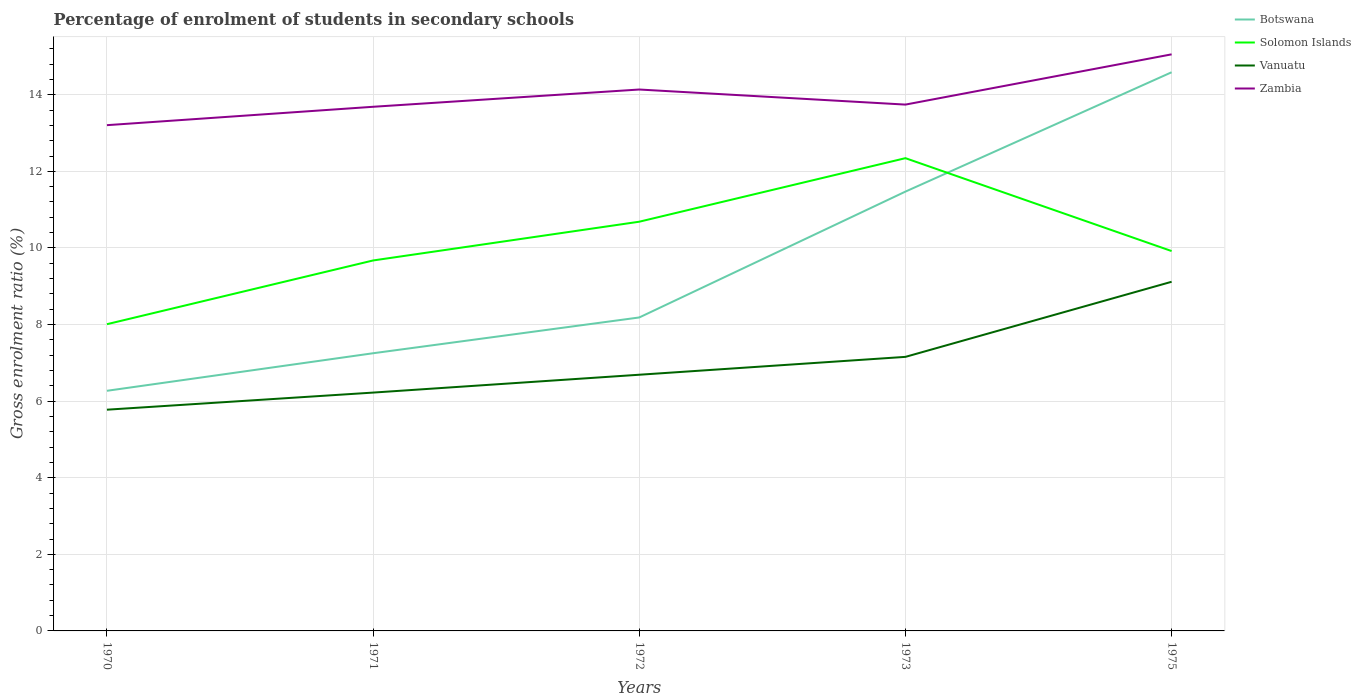Is the number of lines equal to the number of legend labels?
Provide a short and direct response. Yes. Across all years, what is the maximum percentage of students enrolled in secondary schools in Solomon Islands?
Provide a succinct answer. 8.01. In which year was the percentage of students enrolled in secondary schools in Botswana maximum?
Offer a terse response. 1970. What is the total percentage of students enrolled in secondary schools in Zambia in the graph?
Keep it short and to the point. -0.06. What is the difference between the highest and the second highest percentage of students enrolled in secondary schools in Vanuatu?
Make the answer very short. 3.34. Is the percentage of students enrolled in secondary schools in Vanuatu strictly greater than the percentage of students enrolled in secondary schools in Botswana over the years?
Your response must be concise. Yes. How many years are there in the graph?
Ensure brevity in your answer.  5. Are the values on the major ticks of Y-axis written in scientific E-notation?
Your response must be concise. No. How are the legend labels stacked?
Offer a very short reply. Vertical. What is the title of the graph?
Offer a terse response. Percentage of enrolment of students in secondary schools. Does "Guam" appear as one of the legend labels in the graph?
Provide a short and direct response. No. What is the Gross enrolment ratio (%) of Botswana in 1970?
Your answer should be compact. 6.27. What is the Gross enrolment ratio (%) of Solomon Islands in 1970?
Provide a short and direct response. 8.01. What is the Gross enrolment ratio (%) in Vanuatu in 1970?
Your response must be concise. 5.78. What is the Gross enrolment ratio (%) in Zambia in 1970?
Your response must be concise. 13.21. What is the Gross enrolment ratio (%) of Botswana in 1971?
Your answer should be compact. 7.25. What is the Gross enrolment ratio (%) in Solomon Islands in 1971?
Provide a short and direct response. 9.67. What is the Gross enrolment ratio (%) of Vanuatu in 1971?
Give a very brief answer. 6.22. What is the Gross enrolment ratio (%) in Zambia in 1971?
Provide a succinct answer. 13.69. What is the Gross enrolment ratio (%) of Botswana in 1972?
Ensure brevity in your answer.  8.18. What is the Gross enrolment ratio (%) of Solomon Islands in 1972?
Provide a short and direct response. 10.68. What is the Gross enrolment ratio (%) in Vanuatu in 1972?
Provide a succinct answer. 6.69. What is the Gross enrolment ratio (%) of Zambia in 1972?
Keep it short and to the point. 14.14. What is the Gross enrolment ratio (%) of Botswana in 1973?
Give a very brief answer. 11.47. What is the Gross enrolment ratio (%) in Solomon Islands in 1973?
Provide a short and direct response. 12.34. What is the Gross enrolment ratio (%) in Vanuatu in 1973?
Offer a terse response. 7.16. What is the Gross enrolment ratio (%) in Zambia in 1973?
Offer a terse response. 13.74. What is the Gross enrolment ratio (%) in Botswana in 1975?
Give a very brief answer. 14.59. What is the Gross enrolment ratio (%) in Solomon Islands in 1975?
Your answer should be compact. 9.92. What is the Gross enrolment ratio (%) in Vanuatu in 1975?
Your answer should be very brief. 9.12. What is the Gross enrolment ratio (%) of Zambia in 1975?
Make the answer very short. 15.05. Across all years, what is the maximum Gross enrolment ratio (%) of Botswana?
Your response must be concise. 14.59. Across all years, what is the maximum Gross enrolment ratio (%) of Solomon Islands?
Provide a short and direct response. 12.34. Across all years, what is the maximum Gross enrolment ratio (%) in Vanuatu?
Offer a terse response. 9.12. Across all years, what is the maximum Gross enrolment ratio (%) of Zambia?
Provide a short and direct response. 15.05. Across all years, what is the minimum Gross enrolment ratio (%) of Botswana?
Your response must be concise. 6.27. Across all years, what is the minimum Gross enrolment ratio (%) of Solomon Islands?
Ensure brevity in your answer.  8.01. Across all years, what is the minimum Gross enrolment ratio (%) of Vanuatu?
Offer a very short reply. 5.78. Across all years, what is the minimum Gross enrolment ratio (%) of Zambia?
Your response must be concise. 13.21. What is the total Gross enrolment ratio (%) of Botswana in the graph?
Your response must be concise. 47.76. What is the total Gross enrolment ratio (%) in Solomon Islands in the graph?
Your answer should be compact. 50.63. What is the total Gross enrolment ratio (%) in Vanuatu in the graph?
Your response must be concise. 34.96. What is the total Gross enrolment ratio (%) of Zambia in the graph?
Ensure brevity in your answer.  69.82. What is the difference between the Gross enrolment ratio (%) in Botswana in 1970 and that in 1971?
Ensure brevity in your answer.  -0.98. What is the difference between the Gross enrolment ratio (%) of Solomon Islands in 1970 and that in 1971?
Your answer should be very brief. -1.66. What is the difference between the Gross enrolment ratio (%) of Vanuatu in 1970 and that in 1971?
Your answer should be compact. -0.45. What is the difference between the Gross enrolment ratio (%) of Zambia in 1970 and that in 1971?
Your response must be concise. -0.48. What is the difference between the Gross enrolment ratio (%) in Botswana in 1970 and that in 1972?
Your response must be concise. -1.91. What is the difference between the Gross enrolment ratio (%) of Solomon Islands in 1970 and that in 1972?
Your answer should be compact. -2.68. What is the difference between the Gross enrolment ratio (%) in Vanuatu in 1970 and that in 1972?
Ensure brevity in your answer.  -0.91. What is the difference between the Gross enrolment ratio (%) in Zambia in 1970 and that in 1972?
Your answer should be very brief. -0.93. What is the difference between the Gross enrolment ratio (%) in Botswana in 1970 and that in 1973?
Offer a very short reply. -5.2. What is the difference between the Gross enrolment ratio (%) of Solomon Islands in 1970 and that in 1973?
Keep it short and to the point. -4.33. What is the difference between the Gross enrolment ratio (%) in Vanuatu in 1970 and that in 1973?
Offer a very short reply. -1.38. What is the difference between the Gross enrolment ratio (%) in Zambia in 1970 and that in 1973?
Make the answer very short. -0.54. What is the difference between the Gross enrolment ratio (%) of Botswana in 1970 and that in 1975?
Provide a short and direct response. -8.32. What is the difference between the Gross enrolment ratio (%) in Solomon Islands in 1970 and that in 1975?
Ensure brevity in your answer.  -1.91. What is the difference between the Gross enrolment ratio (%) in Vanuatu in 1970 and that in 1975?
Make the answer very short. -3.34. What is the difference between the Gross enrolment ratio (%) of Zambia in 1970 and that in 1975?
Offer a very short reply. -1.85. What is the difference between the Gross enrolment ratio (%) in Botswana in 1971 and that in 1972?
Your answer should be compact. -0.93. What is the difference between the Gross enrolment ratio (%) in Solomon Islands in 1971 and that in 1972?
Your answer should be very brief. -1.01. What is the difference between the Gross enrolment ratio (%) in Vanuatu in 1971 and that in 1972?
Give a very brief answer. -0.47. What is the difference between the Gross enrolment ratio (%) in Zambia in 1971 and that in 1972?
Offer a terse response. -0.45. What is the difference between the Gross enrolment ratio (%) in Botswana in 1971 and that in 1973?
Provide a short and direct response. -4.22. What is the difference between the Gross enrolment ratio (%) in Solomon Islands in 1971 and that in 1973?
Give a very brief answer. -2.67. What is the difference between the Gross enrolment ratio (%) of Vanuatu in 1971 and that in 1973?
Offer a very short reply. -0.93. What is the difference between the Gross enrolment ratio (%) of Zambia in 1971 and that in 1973?
Offer a terse response. -0.06. What is the difference between the Gross enrolment ratio (%) of Botswana in 1971 and that in 1975?
Your answer should be very brief. -7.34. What is the difference between the Gross enrolment ratio (%) in Solomon Islands in 1971 and that in 1975?
Give a very brief answer. -0.25. What is the difference between the Gross enrolment ratio (%) of Vanuatu in 1971 and that in 1975?
Provide a succinct answer. -2.89. What is the difference between the Gross enrolment ratio (%) in Zambia in 1971 and that in 1975?
Ensure brevity in your answer.  -1.37. What is the difference between the Gross enrolment ratio (%) in Botswana in 1972 and that in 1973?
Offer a terse response. -3.29. What is the difference between the Gross enrolment ratio (%) of Solomon Islands in 1972 and that in 1973?
Give a very brief answer. -1.66. What is the difference between the Gross enrolment ratio (%) of Vanuatu in 1972 and that in 1973?
Make the answer very short. -0.47. What is the difference between the Gross enrolment ratio (%) in Zambia in 1972 and that in 1973?
Your answer should be compact. 0.39. What is the difference between the Gross enrolment ratio (%) of Botswana in 1972 and that in 1975?
Your response must be concise. -6.4. What is the difference between the Gross enrolment ratio (%) in Solomon Islands in 1972 and that in 1975?
Your answer should be compact. 0.77. What is the difference between the Gross enrolment ratio (%) in Vanuatu in 1972 and that in 1975?
Your answer should be compact. -2.43. What is the difference between the Gross enrolment ratio (%) in Zambia in 1972 and that in 1975?
Your answer should be very brief. -0.92. What is the difference between the Gross enrolment ratio (%) in Botswana in 1973 and that in 1975?
Offer a very short reply. -3.12. What is the difference between the Gross enrolment ratio (%) in Solomon Islands in 1973 and that in 1975?
Provide a short and direct response. 2.43. What is the difference between the Gross enrolment ratio (%) of Vanuatu in 1973 and that in 1975?
Give a very brief answer. -1.96. What is the difference between the Gross enrolment ratio (%) in Zambia in 1973 and that in 1975?
Provide a succinct answer. -1.31. What is the difference between the Gross enrolment ratio (%) of Botswana in 1970 and the Gross enrolment ratio (%) of Solomon Islands in 1971?
Provide a succinct answer. -3.4. What is the difference between the Gross enrolment ratio (%) of Botswana in 1970 and the Gross enrolment ratio (%) of Vanuatu in 1971?
Your answer should be very brief. 0.05. What is the difference between the Gross enrolment ratio (%) in Botswana in 1970 and the Gross enrolment ratio (%) in Zambia in 1971?
Your answer should be very brief. -7.42. What is the difference between the Gross enrolment ratio (%) of Solomon Islands in 1970 and the Gross enrolment ratio (%) of Vanuatu in 1971?
Your answer should be compact. 1.79. What is the difference between the Gross enrolment ratio (%) in Solomon Islands in 1970 and the Gross enrolment ratio (%) in Zambia in 1971?
Your response must be concise. -5.68. What is the difference between the Gross enrolment ratio (%) in Vanuatu in 1970 and the Gross enrolment ratio (%) in Zambia in 1971?
Keep it short and to the point. -7.91. What is the difference between the Gross enrolment ratio (%) in Botswana in 1970 and the Gross enrolment ratio (%) in Solomon Islands in 1972?
Keep it short and to the point. -4.41. What is the difference between the Gross enrolment ratio (%) of Botswana in 1970 and the Gross enrolment ratio (%) of Vanuatu in 1972?
Offer a terse response. -0.42. What is the difference between the Gross enrolment ratio (%) of Botswana in 1970 and the Gross enrolment ratio (%) of Zambia in 1972?
Make the answer very short. -7.87. What is the difference between the Gross enrolment ratio (%) in Solomon Islands in 1970 and the Gross enrolment ratio (%) in Vanuatu in 1972?
Your response must be concise. 1.32. What is the difference between the Gross enrolment ratio (%) in Solomon Islands in 1970 and the Gross enrolment ratio (%) in Zambia in 1972?
Offer a terse response. -6.13. What is the difference between the Gross enrolment ratio (%) of Vanuatu in 1970 and the Gross enrolment ratio (%) of Zambia in 1972?
Offer a very short reply. -8.36. What is the difference between the Gross enrolment ratio (%) of Botswana in 1970 and the Gross enrolment ratio (%) of Solomon Islands in 1973?
Provide a succinct answer. -6.07. What is the difference between the Gross enrolment ratio (%) in Botswana in 1970 and the Gross enrolment ratio (%) in Vanuatu in 1973?
Provide a succinct answer. -0.89. What is the difference between the Gross enrolment ratio (%) in Botswana in 1970 and the Gross enrolment ratio (%) in Zambia in 1973?
Offer a terse response. -7.47. What is the difference between the Gross enrolment ratio (%) of Solomon Islands in 1970 and the Gross enrolment ratio (%) of Vanuatu in 1973?
Your answer should be very brief. 0.85. What is the difference between the Gross enrolment ratio (%) of Solomon Islands in 1970 and the Gross enrolment ratio (%) of Zambia in 1973?
Your answer should be compact. -5.73. What is the difference between the Gross enrolment ratio (%) in Vanuatu in 1970 and the Gross enrolment ratio (%) in Zambia in 1973?
Your response must be concise. -7.97. What is the difference between the Gross enrolment ratio (%) of Botswana in 1970 and the Gross enrolment ratio (%) of Solomon Islands in 1975?
Give a very brief answer. -3.65. What is the difference between the Gross enrolment ratio (%) in Botswana in 1970 and the Gross enrolment ratio (%) in Vanuatu in 1975?
Keep it short and to the point. -2.85. What is the difference between the Gross enrolment ratio (%) of Botswana in 1970 and the Gross enrolment ratio (%) of Zambia in 1975?
Your answer should be very brief. -8.78. What is the difference between the Gross enrolment ratio (%) in Solomon Islands in 1970 and the Gross enrolment ratio (%) in Vanuatu in 1975?
Provide a short and direct response. -1.11. What is the difference between the Gross enrolment ratio (%) in Solomon Islands in 1970 and the Gross enrolment ratio (%) in Zambia in 1975?
Offer a terse response. -7.05. What is the difference between the Gross enrolment ratio (%) of Vanuatu in 1970 and the Gross enrolment ratio (%) of Zambia in 1975?
Ensure brevity in your answer.  -9.28. What is the difference between the Gross enrolment ratio (%) of Botswana in 1971 and the Gross enrolment ratio (%) of Solomon Islands in 1972?
Your answer should be compact. -3.43. What is the difference between the Gross enrolment ratio (%) in Botswana in 1971 and the Gross enrolment ratio (%) in Vanuatu in 1972?
Offer a very short reply. 0.56. What is the difference between the Gross enrolment ratio (%) in Botswana in 1971 and the Gross enrolment ratio (%) in Zambia in 1972?
Your answer should be compact. -6.89. What is the difference between the Gross enrolment ratio (%) in Solomon Islands in 1971 and the Gross enrolment ratio (%) in Vanuatu in 1972?
Give a very brief answer. 2.98. What is the difference between the Gross enrolment ratio (%) in Solomon Islands in 1971 and the Gross enrolment ratio (%) in Zambia in 1972?
Your answer should be compact. -4.46. What is the difference between the Gross enrolment ratio (%) of Vanuatu in 1971 and the Gross enrolment ratio (%) of Zambia in 1972?
Ensure brevity in your answer.  -7.91. What is the difference between the Gross enrolment ratio (%) in Botswana in 1971 and the Gross enrolment ratio (%) in Solomon Islands in 1973?
Keep it short and to the point. -5.09. What is the difference between the Gross enrolment ratio (%) in Botswana in 1971 and the Gross enrolment ratio (%) in Vanuatu in 1973?
Offer a very short reply. 0.09. What is the difference between the Gross enrolment ratio (%) in Botswana in 1971 and the Gross enrolment ratio (%) in Zambia in 1973?
Provide a succinct answer. -6.49. What is the difference between the Gross enrolment ratio (%) of Solomon Islands in 1971 and the Gross enrolment ratio (%) of Vanuatu in 1973?
Offer a very short reply. 2.52. What is the difference between the Gross enrolment ratio (%) of Solomon Islands in 1971 and the Gross enrolment ratio (%) of Zambia in 1973?
Offer a terse response. -4.07. What is the difference between the Gross enrolment ratio (%) of Vanuatu in 1971 and the Gross enrolment ratio (%) of Zambia in 1973?
Offer a terse response. -7.52. What is the difference between the Gross enrolment ratio (%) in Botswana in 1971 and the Gross enrolment ratio (%) in Solomon Islands in 1975?
Provide a succinct answer. -2.67. What is the difference between the Gross enrolment ratio (%) in Botswana in 1971 and the Gross enrolment ratio (%) in Vanuatu in 1975?
Keep it short and to the point. -1.87. What is the difference between the Gross enrolment ratio (%) of Botswana in 1971 and the Gross enrolment ratio (%) of Zambia in 1975?
Provide a short and direct response. -7.8. What is the difference between the Gross enrolment ratio (%) in Solomon Islands in 1971 and the Gross enrolment ratio (%) in Vanuatu in 1975?
Your answer should be very brief. 0.56. What is the difference between the Gross enrolment ratio (%) in Solomon Islands in 1971 and the Gross enrolment ratio (%) in Zambia in 1975?
Provide a succinct answer. -5.38. What is the difference between the Gross enrolment ratio (%) of Vanuatu in 1971 and the Gross enrolment ratio (%) of Zambia in 1975?
Provide a succinct answer. -8.83. What is the difference between the Gross enrolment ratio (%) of Botswana in 1972 and the Gross enrolment ratio (%) of Solomon Islands in 1973?
Ensure brevity in your answer.  -4.16. What is the difference between the Gross enrolment ratio (%) of Botswana in 1972 and the Gross enrolment ratio (%) of Zambia in 1973?
Make the answer very short. -5.56. What is the difference between the Gross enrolment ratio (%) of Solomon Islands in 1972 and the Gross enrolment ratio (%) of Vanuatu in 1973?
Provide a succinct answer. 3.53. What is the difference between the Gross enrolment ratio (%) in Solomon Islands in 1972 and the Gross enrolment ratio (%) in Zambia in 1973?
Offer a terse response. -3.06. What is the difference between the Gross enrolment ratio (%) of Vanuatu in 1972 and the Gross enrolment ratio (%) of Zambia in 1973?
Offer a terse response. -7.05. What is the difference between the Gross enrolment ratio (%) in Botswana in 1972 and the Gross enrolment ratio (%) in Solomon Islands in 1975?
Offer a terse response. -1.73. What is the difference between the Gross enrolment ratio (%) of Botswana in 1972 and the Gross enrolment ratio (%) of Vanuatu in 1975?
Make the answer very short. -0.93. What is the difference between the Gross enrolment ratio (%) of Botswana in 1972 and the Gross enrolment ratio (%) of Zambia in 1975?
Your response must be concise. -6.87. What is the difference between the Gross enrolment ratio (%) of Solomon Islands in 1972 and the Gross enrolment ratio (%) of Vanuatu in 1975?
Your response must be concise. 1.57. What is the difference between the Gross enrolment ratio (%) of Solomon Islands in 1972 and the Gross enrolment ratio (%) of Zambia in 1975?
Give a very brief answer. -4.37. What is the difference between the Gross enrolment ratio (%) of Vanuatu in 1972 and the Gross enrolment ratio (%) of Zambia in 1975?
Make the answer very short. -8.37. What is the difference between the Gross enrolment ratio (%) in Botswana in 1973 and the Gross enrolment ratio (%) in Solomon Islands in 1975?
Provide a short and direct response. 1.55. What is the difference between the Gross enrolment ratio (%) of Botswana in 1973 and the Gross enrolment ratio (%) of Vanuatu in 1975?
Your answer should be very brief. 2.35. What is the difference between the Gross enrolment ratio (%) in Botswana in 1973 and the Gross enrolment ratio (%) in Zambia in 1975?
Your answer should be very brief. -3.58. What is the difference between the Gross enrolment ratio (%) of Solomon Islands in 1973 and the Gross enrolment ratio (%) of Vanuatu in 1975?
Make the answer very short. 3.23. What is the difference between the Gross enrolment ratio (%) in Solomon Islands in 1973 and the Gross enrolment ratio (%) in Zambia in 1975?
Offer a very short reply. -2.71. What is the difference between the Gross enrolment ratio (%) of Vanuatu in 1973 and the Gross enrolment ratio (%) of Zambia in 1975?
Ensure brevity in your answer.  -7.9. What is the average Gross enrolment ratio (%) in Botswana per year?
Make the answer very short. 9.55. What is the average Gross enrolment ratio (%) in Solomon Islands per year?
Make the answer very short. 10.13. What is the average Gross enrolment ratio (%) in Vanuatu per year?
Provide a short and direct response. 6.99. What is the average Gross enrolment ratio (%) of Zambia per year?
Give a very brief answer. 13.96. In the year 1970, what is the difference between the Gross enrolment ratio (%) of Botswana and Gross enrolment ratio (%) of Solomon Islands?
Give a very brief answer. -1.74. In the year 1970, what is the difference between the Gross enrolment ratio (%) in Botswana and Gross enrolment ratio (%) in Vanuatu?
Ensure brevity in your answer.  0.49. In the year 1970, what is the difference between the Gross enrolment ratio (%) of Botswana and Gross enrolment ratio (%) of Zambia?
Your response must be concise. -6.94. In the year 1970, what is the difference between the Gross enrolment ratio (%) of Solomon Islands and Gross enrolment ratio (%) of Vanuatu?
Make the answer very short. 2.23. In the year 1970, what is the difference between the Gross enrolment ratio (%) of Solomon Islands and Gross enrolment ratio (%) of Zambia?
Your answer should be compact. -5.2. In the year 1970, what is the difference between the Gross enrolment ratio (%) in Vanuatu and Gross enrolment ratio (%) in Zambia?
Provide a short and direct response. -7.43. In the year 1971, what is the difference between the Gross enrolment ratio (%) in Botswana and Gross enrolment ratio (%) in Solomon Islands?
Provide a succinct answer. -2.42. In the year 1971, what is the difference between the Gross enrolment ratio (%) of Botswana and Gross enrolment ratio (%) of Vanuatu?
Offer a very short reply. 1.03. In the year 1971, what is the difference between the Gross enrolment ratio (%) of Botswana and Gross enrolment ratio (%) of Zambia?
Provide a succinct answer. -6.43. In the year 1971, what is the difference between the Gross enrolment ratio (%) of Solomon Islands and Gross enrolment ratio (%) of Vanuatu?
Your answer should be compact. 3.45. In the year 1971, what is the difference between the Gross enrolment ratio (%) of Solomon Islands and Gross enrolment ratio (%) of Zambia?
Provide a succinct answer. -4.01. In the year 1971, what is the difference between the Gross enrolment ratio (%) of Vanuatu and Gross enrolment ratio (%) of Zambia?
Your response must be concise. -7.46. In the year 1972, what is the difference between the Gross enrolment ratio (%) in Botswana and Gross enrolment ratio (%) in Solomon Islands?
Offer a terse response. -2.5. In the year 1972, what is the difference between the Gross enrolment ratio (%) in Botswana and Gross enrolment ratio (%) in Vanuatu?
Your response must be concise. 1.5. In the year 1972, what is the difference between the Gross enrolment ratio (%) of Botswana and Gross enrolment ratio (%) of Zambia?
Give a very brief answer. -5.95. In the year 1972, what is the difference between the Gross enrolment ratio (%) in Solomon Islands and Gross enrolment ratio (%) in Vanuatu?
Your answer should be very brief. 4. In the year 1972, what is the difference between the Gross enrolment ratio (%) in Solomon Islands and Gross enrolment ratio (%) in Zambia?
Give a very brief answer. -3.45. In the year 1972, what is the difference between the Gross enrolment ratio (%) of Vanuatu and Gross enrolment ratio (%) of Zambia?
Provide a short and direct response. -7.45. In the year 1973, what is the difference between the Gross enrolment ratio (%) in Botswana and Gross enrolment ratio (%) in Solomon Islands?
Provide a short and direct response. -0.87. In the year 1973, what is the difference between the Gross enrolment ratio (%) of Botswana and Gross enrolment ratio (%) of Vanuatu?
Make the answer very short. 4.32. In the year 1973, what is the difference between the Gross enrolment ratio (%) of Botswana and Gross enrolment ratio (%) of Zambia?
Provide a succinct answer. -2.27. In the year 1973, what is the difference between the Gross enrolment ratio (%) in Solomon Islands and Gross enrolment ratio (%) in Vanuatu?
Your answer should be very brief. 5.19. In the year 1973, what is the difference between the Gross enrolment ratio (%) of Solomon Islands and Gross enrolment ratio (%) of Zambia?
Your answer should be compact. -1.4. In the year 1973, what is the difference between the Gross enrolment ratio (%) in Vanuatu and Gross enrolment ratio (%) in Zambia?
Provide a short and direct response. -6.59. In the year 1975, what is the difference between the Gross enrolment ratio (%) in Botswana and Gross enrolment ratio (%) in Solomon Islands?
Your response must be concise. 4.67. In the year 1975, what is the difference between the Gross enrolment ratio (%) of Botswana and Gross enrolment ratio (%) of Vanuatu?
Your answer should be very brief. 5.47. In the year 1975, what is the difference between the Gross enrolment ratio (%) of Botswana and Gross enrolment ratio (%) of Zambia?
Offer a very short reply. -0.47. In the year 1975, what is the difference between the Gross enrolment ratio (%) of Solomon Islands and Gross enrolment ratio (%) of Vanuatu?
Ensure brevity in your answer.  0.8. In the year 1975, what is the difference between the Gross enrolment ratio (%) in Solomon Islands and Gross enrolment ratio (%) in Zambia?
Your answer should be very brief. -5.14. In the year 1975, what is the difference between the Gross enrolment ratio (%) of Vanuatu and Gross enrolment ratio (%) of Zambia?
Provide a succinct answer. -5.94. What is the ratio of the Gross enrolment ratio (%) in Botswana in 1970 to that in 1971?
Provide a short and direct response. 0.86. What is the ratio of the Gross enrolment ratio (%) of Solomon Islands in 1970 to that in 1971?
Offer a very short reply. 0.83. What is the ratio of the Gross enrolment ratio (%) of Vanuatu in 1970 to that in 1971?
Your answer should be compact. 0.93. What is the ratio of the Gross enrolment ratio (%) of Zambia in 1970 to that in 1971?
Offer a terse response. 0.96. What is the ratio of the Gross enrolment ratio (%) in Botswana in 1970 to that in 1972?
Your response must be concise. 0.77. What is the ratio of the Gross enrolment ratio (%) in Solomon Islands in 1970 to that in 1972?
Your answer should be very brief. 0.75. What is the ratio of the Gross enrolment ratio (%) of Vanuatu in 1970 to that in 1972?
Your response must be concise. 0.86. What is the ratio of the Gross enrolment ratio (%) in Zambia in 1970 to that in 1972?
Give a very brief answer. 0.93. What is the ratio of the Gross enrolment ratio (%) in Botswana in 1970 to that in 1973?
Your answer should be compact. 0.55. What is the ratio of the Gross enrolment ratio (%) of Solomon Islands in 1970 to that in 1973?
Keep it short and to the point. 0.65. What is the ratio of the Gross enrolment ratio (%) of Vanuatu in 1970 to that in 1973?
Provide a short and direct response. 0.81. What is the ratio of the Gross enrolment ratio (%) in Zambia in 1970 to that in 1973?
Your answer should be very brief. 0.96. What is the ratio of the Gross enrolment ratio (%) of Botswana in 1970 to that in 1975?
Your answer should be very brief. 0.43. What is the ratio of the Gross enrolment ratio (%) in Solomon Islands in 1970 to that in 1975?
Ensure brevity in your answer.  0.81. What is the ratio of the Gross enrolment ratio (%) of Vanuatu in 1970 to that in 1975?
Keep it short and to the point. 0.63. What is the ratio of the Gross enrolment ratio (%) in Zambia in 1970 to that in 1975?
Provide a succinct answer. 0.88. What is the ratio of the Gross enrolment ratio (%) in Botswana in 1971 to that in 1972?
Offer a very short reply. 0.89. What is the ratio of the Gross enrolment ratio (%) of Solomon Islands in 1971 to that in 1972?
Keep it short and to the point. 0.91. What is the ratio of the Gross enrolment ratio (%) of Vanuatu in 1971 to that in 1972?
Provide a short and direct response. 0.93. What is the ratio of the Gross enrolment ratio (%) in Zambia in 1971 to that in 1972?
Provide a short and direct response. 0.97. What is the ratio of the Gross enrolment ratio (%) in Botswana in 1971 to that in 1973?
Give a very brief answer. 0.63. What is the ratio of the Gross enrolment ratio (%) in Solomon Islands in 1971 to that in 1973?
Offer a very short reply. 0.78. What is the ratio of the Gross enrolment ratio (%) in Vanuatu in 1971 to that in 1973?
Keep it short and to the point. 0.87. What is the ratio of the Gross enrolment ratio (%) of Zambia in 1971 to that in 1973?
Ensure brevity in your answer.  1. What is the ratio of the Gross enrolment ratio (%) of Botswana in 1971 to that in 1975?
Give a very brief answer. 0.5. What is the ratio of the Gross enrolment ratio (%) in Solomon Islands in 1971 to that in 1975?
Make the answer very short. 0.98. What is the ratio of the Gross enrolment ratio (%) of Vanuatu in 1971 to that in 1975?
Your answer should be very brief. 0.68. What is the ratio of the Gross enrolment ratio (%) in Botswana in 1972 to that in 1973?
Offer a terse response. 0.71. What is the ratio of the Gross enrolment ratio (%) of Solomon Islands in 1972 to that in 1973?
Your answer should be very brief. 0.87. What is the ratio of the Gross enrolment ratio (%) of Vanuatu in 1972 to that in 1973?
Your answer should be compact. 0.93. What is the ratio of the Gross enrolment ratio (%) of Zambia in 1972 to that in 1973?
Provide a short and direct response. 1.03. What is the ratio of the Gross enrolment ratio (%) in Botswana in 1972 to that in 1975?
Your answer should be very brief. 0.56. What is the ratio of the Gross enrolment ratio (%) in Solomon Islands in 1972 to that in 1975?
Give a very brief answer. 1.08. What is the ratio of the Gross enrolment ratio (%) in Vanuatu in 1972 to that in 1975?
Ensure brevity in your answer.  0.73. What is the ratio of the Gross enrolment ratio (%) of Zambia in 1972 to that in 1975?
Provide a succinct answer. 0.94. What is the ratio of the Gross enrolment ratio (%) in Botswana in 1973 to that in 1975?
Ensure brevity in your answer.  0.79. What is the ratio of the Gross enrolment ratio (%) of Solomon Islands in 1973 to that in 1975?
Offer a very short reply. 1.24. What is the ratio of the Gross enrolment ratio (%) of Vanuatu in 1973 to that in 1975?
Your answer should be compact. 0.78. What is the ratio of the Gross enrolment ratio (%) in Zambia in 1973 to that in 1975?
Your answer should be compact. 0.91. What is the difference between the highest and the second highest Gross enrolment ratio (%) of Botswana?
Provide a succinct answer. 3.12. What is the difference between the highest and the second highest Gross enrolment ratio (%) in Solomon Islands?
Offer a terse response. 1.66. What is the difference between the highest and the second highest Gross enrolment ratio (%) of Vanuatu?
Provide a succinct answer. 1.96. What is the difference between the highest and the second highest Gross enrolment ratio (%) in Zambia?
Provide a short and direct response. 0.92. What is the difference between the highest and the lowest Gross enrolment ratio (%) in Botswana?
Provide a succinct answer. 8.32. What is the difference between the highest and the lowest Gross enrolment ratio (%) of Solomon Islands?
Give a very brief answer. 4.33. What is the difference between the highest and the lowest Gross enrolment ratio (%) in Vanuatu?
Provide a short and direct response. 3.34. What is the difference between the highest and the lowest Gross enrolment ratio (%) in Zambia?
Your response must be concise. 1.85. 